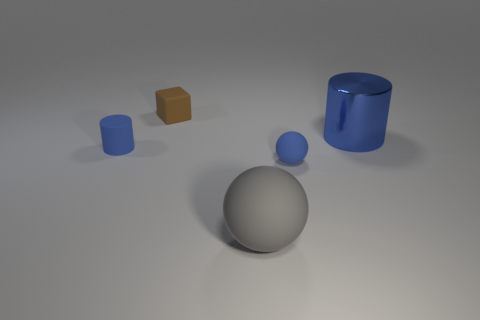Add 3 tiny cyan rubber cylinders. How many objects exist? 8 Subtract all balls. How many objects are left? 3 Add 1 big blue cylinders. How many big blue cylinders are left? 2 Add 1 brown things. How many brown things exist? 2 Subtract 0 blue cubes. How many objects are left? 5 Subtract all tiny blue shiny spheres. Subtract all large gray objects. How many objects are left? 4 